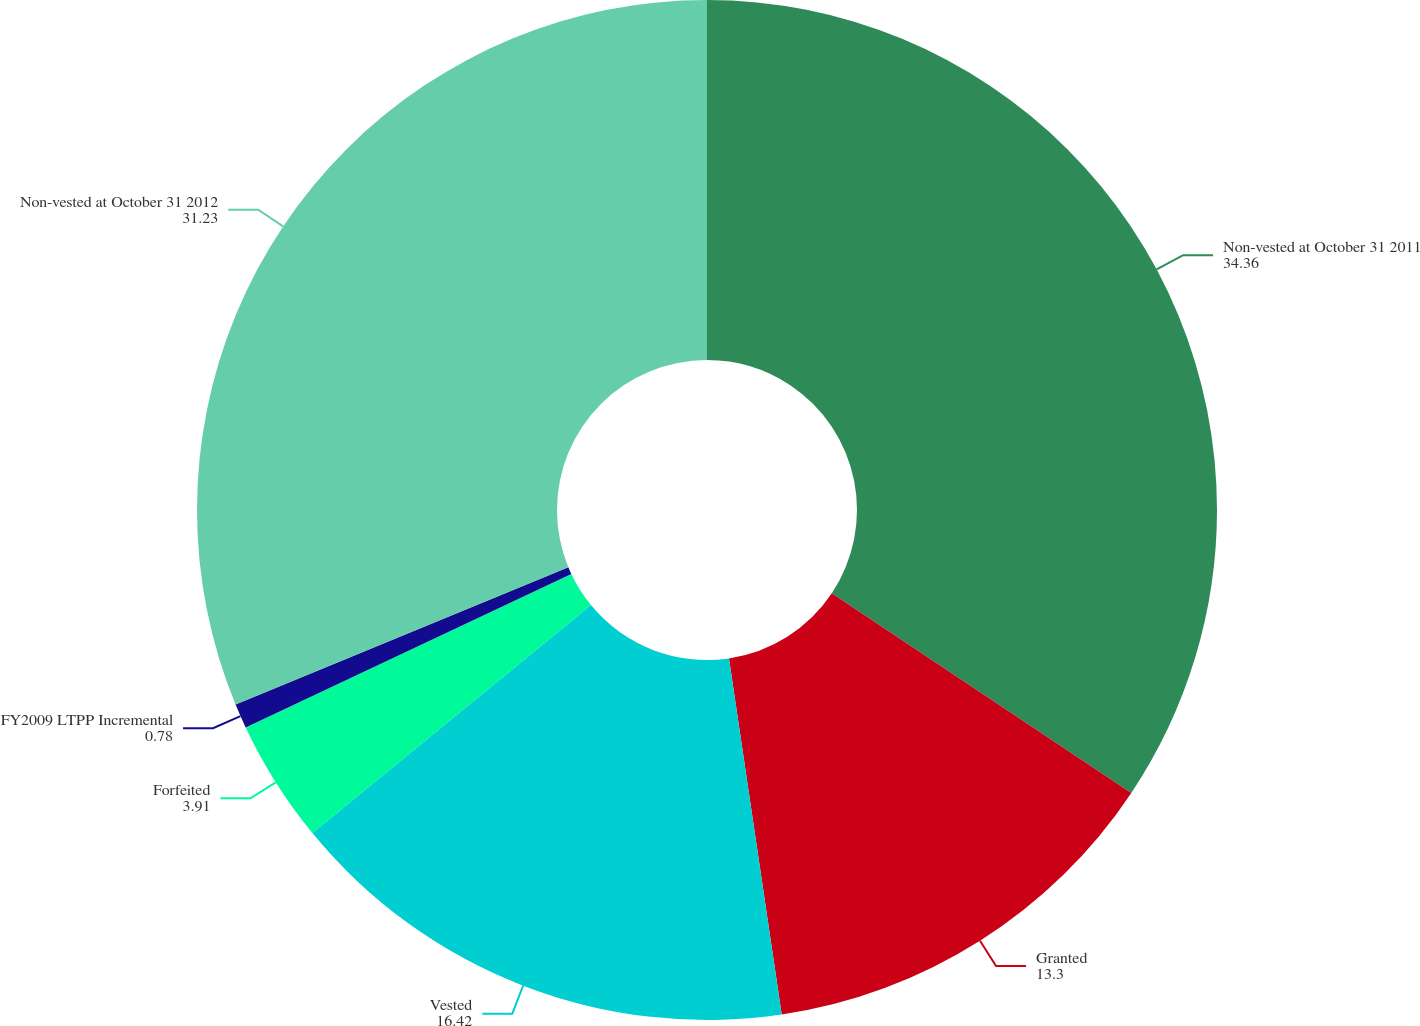Convert chart to OTSL. <chart><loc_0><loc_0><loc_500><loc_500><pie_chart><fcel>Non-vested at October 31 2011<fcel>Granted<fcel>Vested<fcel>Forfeited<fcel>FY2009 LTPP Incremental<fcel>Non-vested at October 31 2012<nl><fcel>34.36%<fcel>13.3%<fcel>16.42%<fcel>3.91%<fcel>0.78%<fcel>31.23%<nl></chart> 